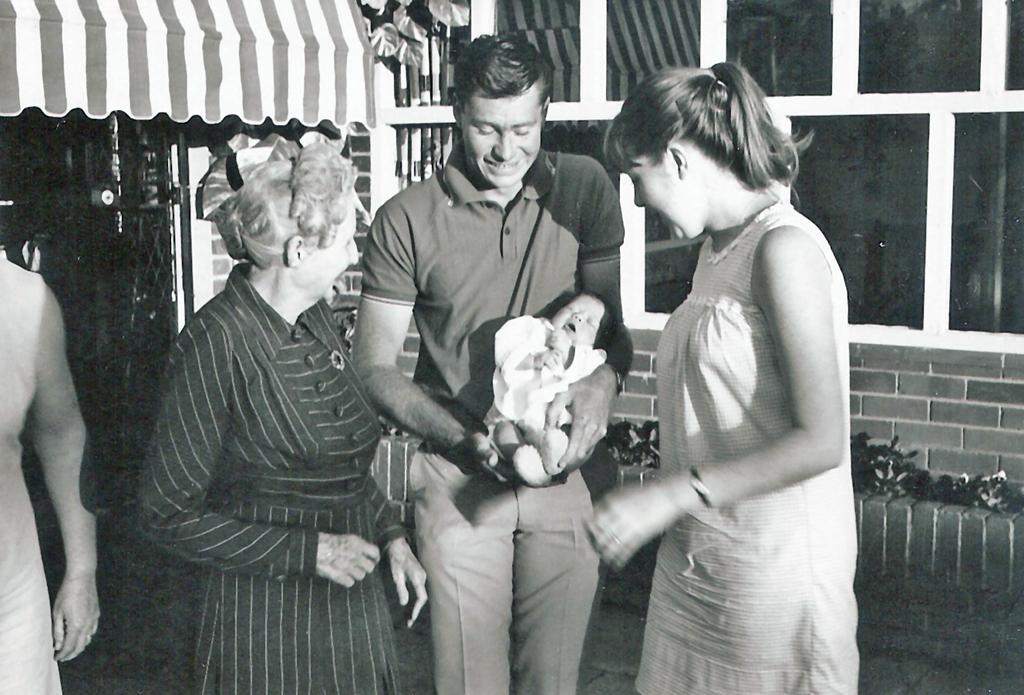Please provide a concise description of this image. In this image we can see black and white picture of a group of people standing on the ground. One person is holding a baby in his hands. On the left side of the image we can see a gate and a tent. At the top of the image we can see a building with windows and some plants. 